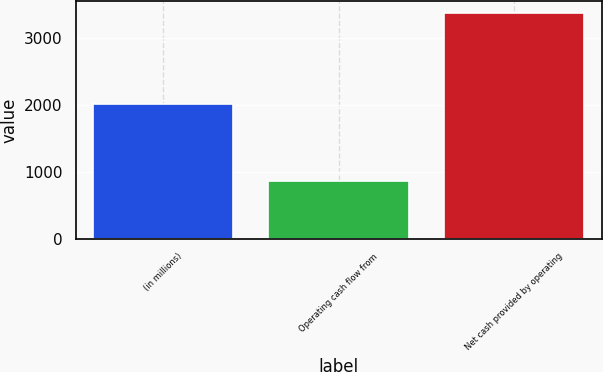Convert chart. <chart><loc_0><loc_0><loc_500><loc_500><bar_chart><fcel>(in millions)<fcel>Operating cash flow from<fcel>Net cash provided by operating<nl><fcel>2016<fcel>864<fcel>3383<nl></chart> 